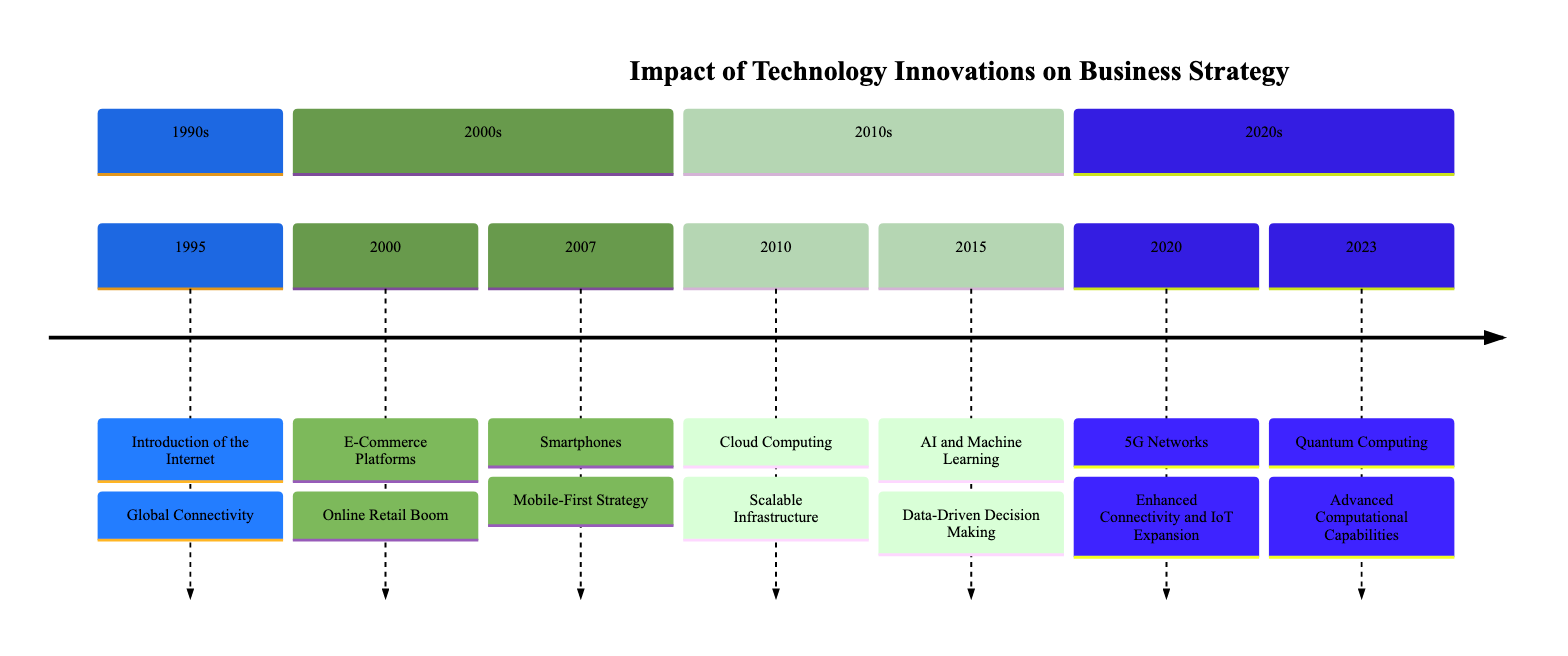What technology was introduced in 1995? According to the timeline, the technology introduced in 1995 is the Internet. This is indicated as the first entry in the timeline.
Answer: Internet What was the business outcome of the Cloud Computing technology in 2010? The timeline states that the business outcome for Cloud Computing in 2010 was "Scalable Infrastructure." This encapsulates the benefits realized by businesses that adopted cloud solutions.
Answer: Scalable Infrastructure How many different technologies are listed in the timeline? The timeline contains a total of six different technologies, each occurring in different years from 1995 to 2023. By counting the entries in the timeline, the total is confirmed.
Answer: 6 Which year saw the introduction of Artificial Intelligence and Machine Learning? The timeline indicates that Artificial Intelligence and Machine Learning were introduced in the year 2015. This entry corresponds to the fifth point on the diagram.
Answer: 2015 What is the business outcome of Quantum Computing in 2023? In the timeline, the business outcome listed for Quantum Computing in 2023 is "Advanced Computational Capabilities," reflecting the potential impacts in various sectors.
Answer: Advanced Computational Capabilities What is the primary benefit of introducing 5G Networks according to the timeline? According to the timeline, the primary benefit of the introduction of 5G Networks in 2020 is "Enhanced Connectivity and IoT Expansion." This indicates how this technology impacted business operations and opportunities.
Answer: Enhanced Connectivity and IoT Expansion List all the business outcomes in chronological order. The timeline details the business outcomes as follows: Global Connectivity, Online Retail Boom, Mobile-First Strategy, Scalable Infrastructure, Data-Driven Decision Making, Enhanced Connectivity and IoT Expansion, Advanced Computational Capabilities. This list can be constructed by extracting the outcomes corresponding to each technology entry in order.
Answer: Global Connectivity, Online Retail Boom, Mobile-First Strategy, Scalable Infrastructure, Data-Driven Decision Making, Enhanced Connectivity and IoT Expansion, Advanced Computational Capabilities 